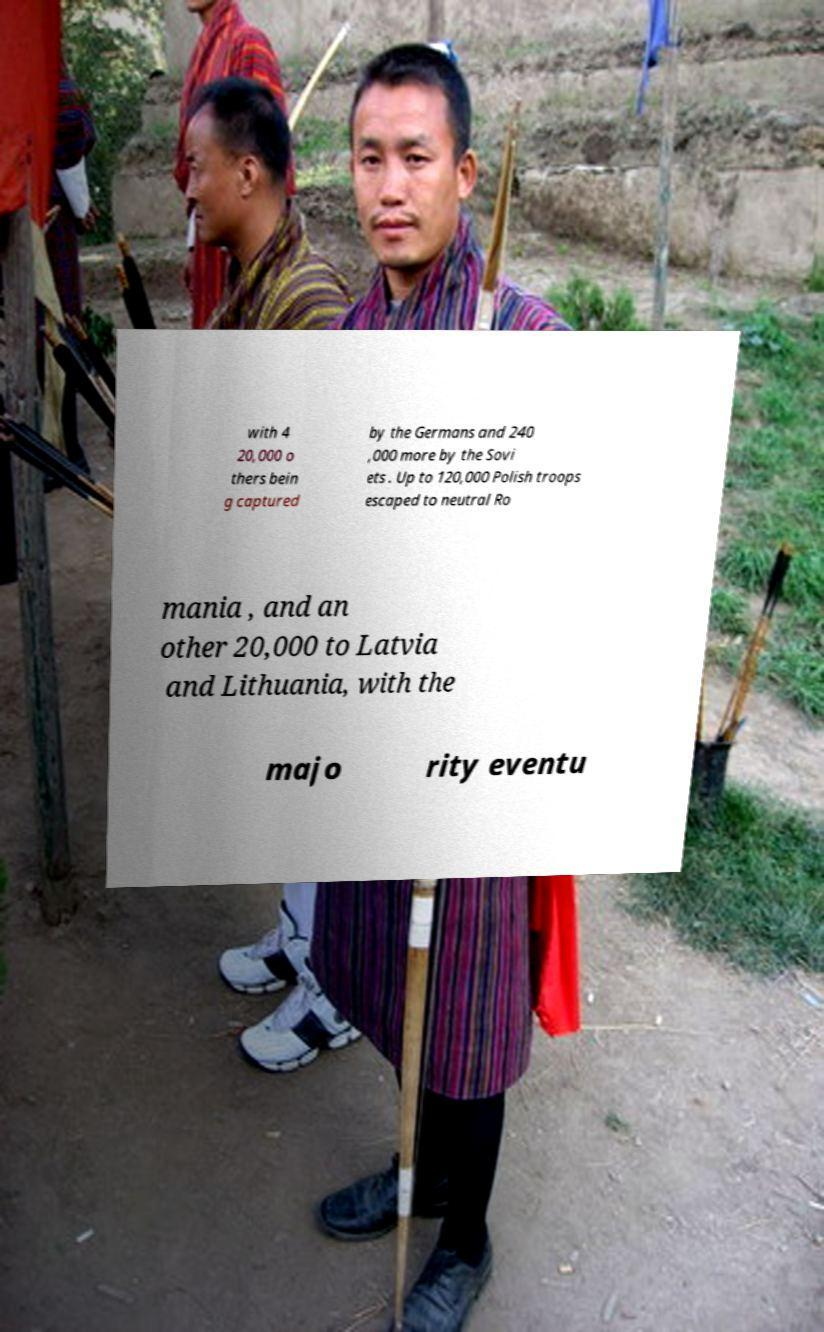There's text embedded in this image that I need extracted. Can you transcribe it verbatim? with 4 20,000 o thers bein g captured by the Germans and 240 ,000 more by the Sovi ets . Up to 120,000 Polish troops escaped to neutral Ro mania , and an other 20,000 to Latvia and Lithuania, with the majo rity eventu 